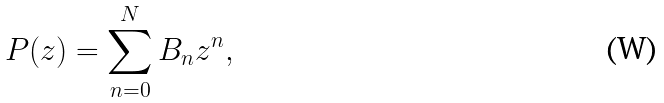Convert formula to latex. <formula><loc_0><loc_0><loc_500><loc_500>P ( z ) = \sum _ { n = 0 } ^ { N } B _ { n } z ^ { n } ,</formula> 